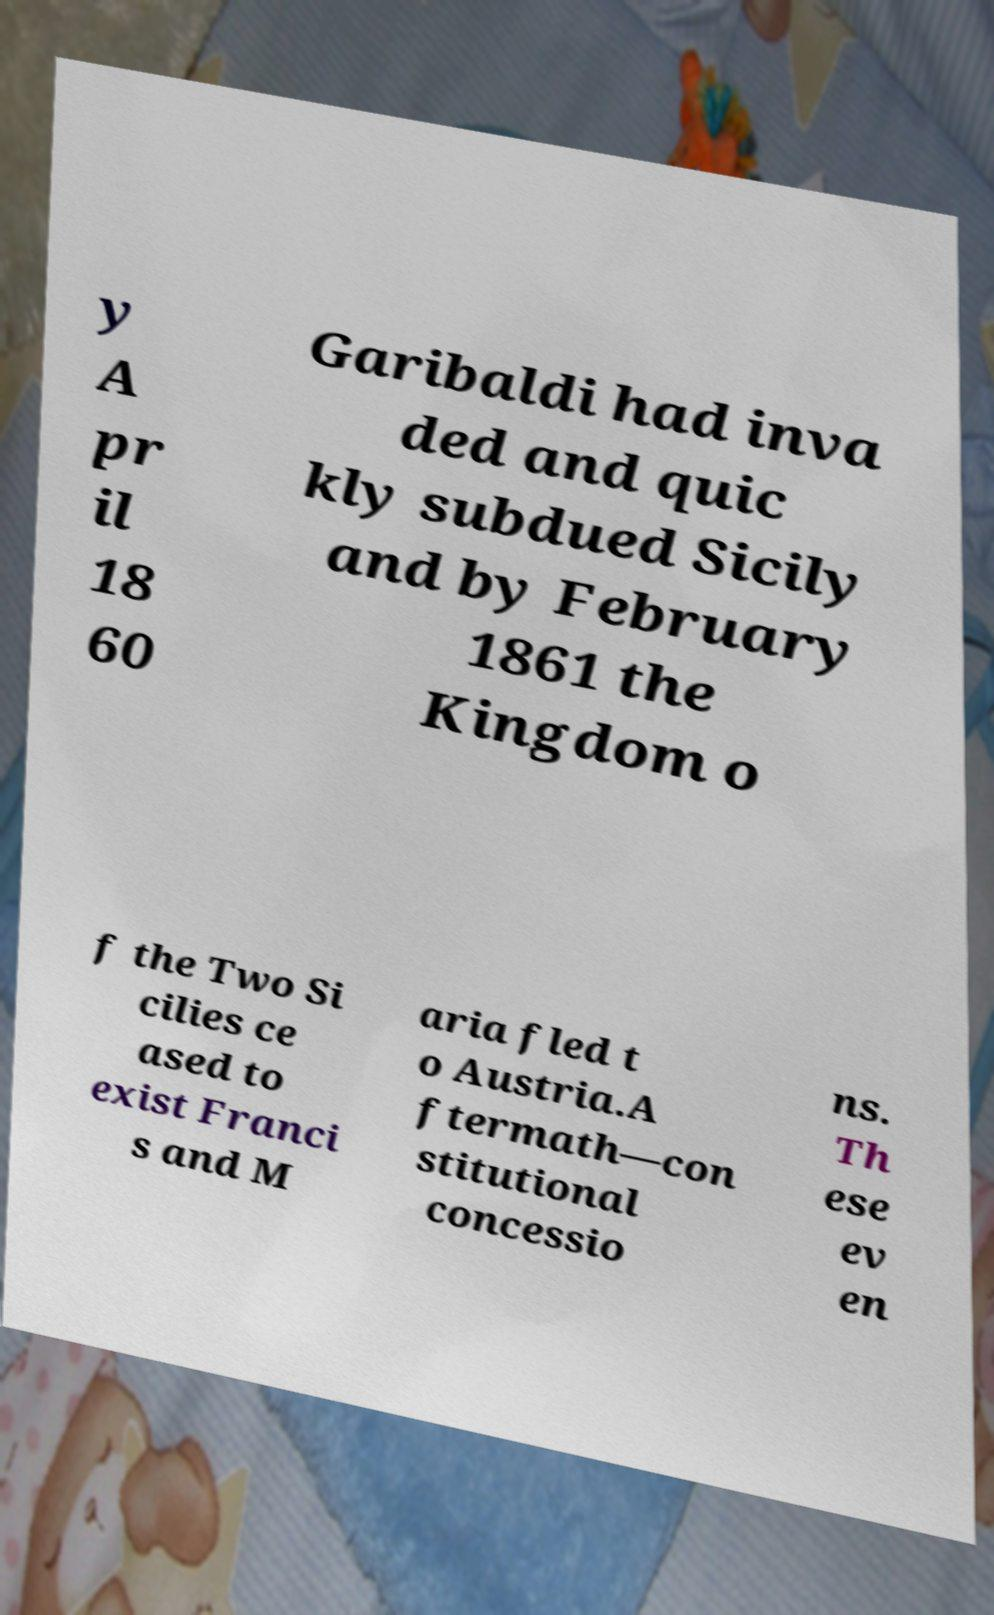For documentation purposes, I need the text within this image transcribed. Could you provide that? y A pr il 18 60 Garibaldi had inva ded and quic kly subdued Sicily and by February 1861 the Kingdom o f the Two Si cilies ce ased to exist Franci s and M aria fled t o Austria.A ftermath—con stitutional concessio ns. Th ese ev en 